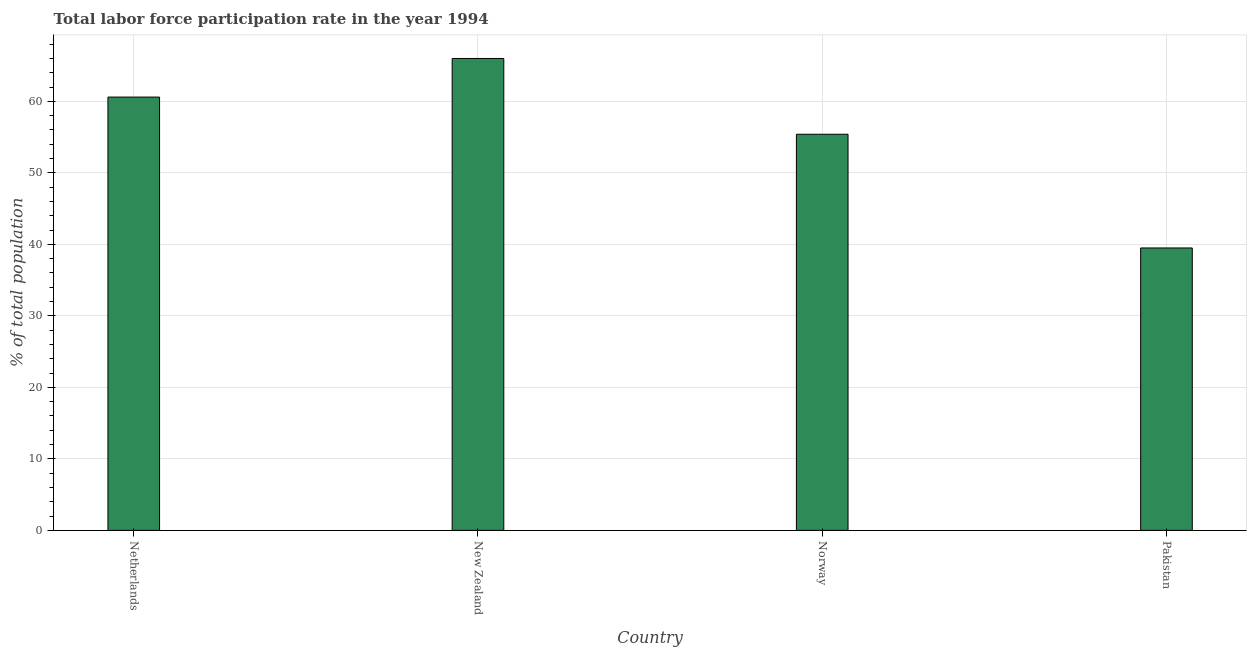What is the title of the graph?
Provide a short and direct response. Total labor force participation rate in the year 1994. What is the label or title of the Y-axis?
Make the answer very short. % of total population. What is the total labor force participation rate in Netherlands?
Provide a succinct answer. 60.6. Across all countries, what is the minimum total labor force participation rate?
Keep it short and to the point. 39.5. In which country was the total labor force participation rate maximum?
Offer a very short reply. New Zealand. In which country was the total labor force participation rate minimum?
Offer a terse response. Pakistan. What is the sum of the total labor force participation rate?
Offer a terse response. 221.5. What is the difference between the total labor force participation rate in Netherlands and Norway?
Give a very brief answer. 5.2. What is the average total labor force participation rate per country?
Offer a terse response. 55.38. In how many countries, is the total labor force participation rate greater than 28 %?
Offer a very short reply. 4. What is the ratio of the total labor force participation rate in New Zealand to that in Pakistan?
Offer a very short reply. 1.67. Is the total labor force participation rate in New Zealand less than that in Pakistan?
Provide a succinct answer. No. Is the difference between the total labor force participation rate in Netherlands and Norway greater than the difference between any two countries?
Your answer should be very brief. No. What is the difference between the highest and the lowest total labor force participation rate?
Provide a succinct answer. 26.5. How many bars are there?
Offer a terse response. 4. How many countries are there in the graph?
Offer a very short reply. 4. What is the % of total population of Netherlands?
Make the answer very short. 60.6. What is the % of total population of Norway?
Provide a succinct answer. 55.4. What is the % of total population in Pakistan?
Offer a very short reply. 39.5. What is the difference between the % of total population in Netherlands and Norway?
Offer a very short reply. 5.2. What is the difference between the % of total population in Netherlands and Pakistan?
Ensure brevity in your answer.  21.1. What is the difference between the % of total population in New Zealand and Pakistan?
Make the answer very short. 26.5. What is the ratio of the % of total population in Netherlands to that in New Zealand?
Offer a very short reply. 0.92. What is the ratio of the % of total population in Netherlands to that in Norway?
Provide a succinct answer. 1.09. What is the ratio of the % of total population in Netherlands to that in Pakistan?
Your answer should be compact. 1.53. What is the ratio of the % of total population in New Zealand to that in Norway?
Keep it short and to the point. 1.19. What is the ratio of the % of total population in New Zealand to that in Pakistan?
Keep it short and to the point. 1.67. What is the ratio of the % of total population in Norway to that in Pakistan?
Keep it short and to the point. 1.4. 